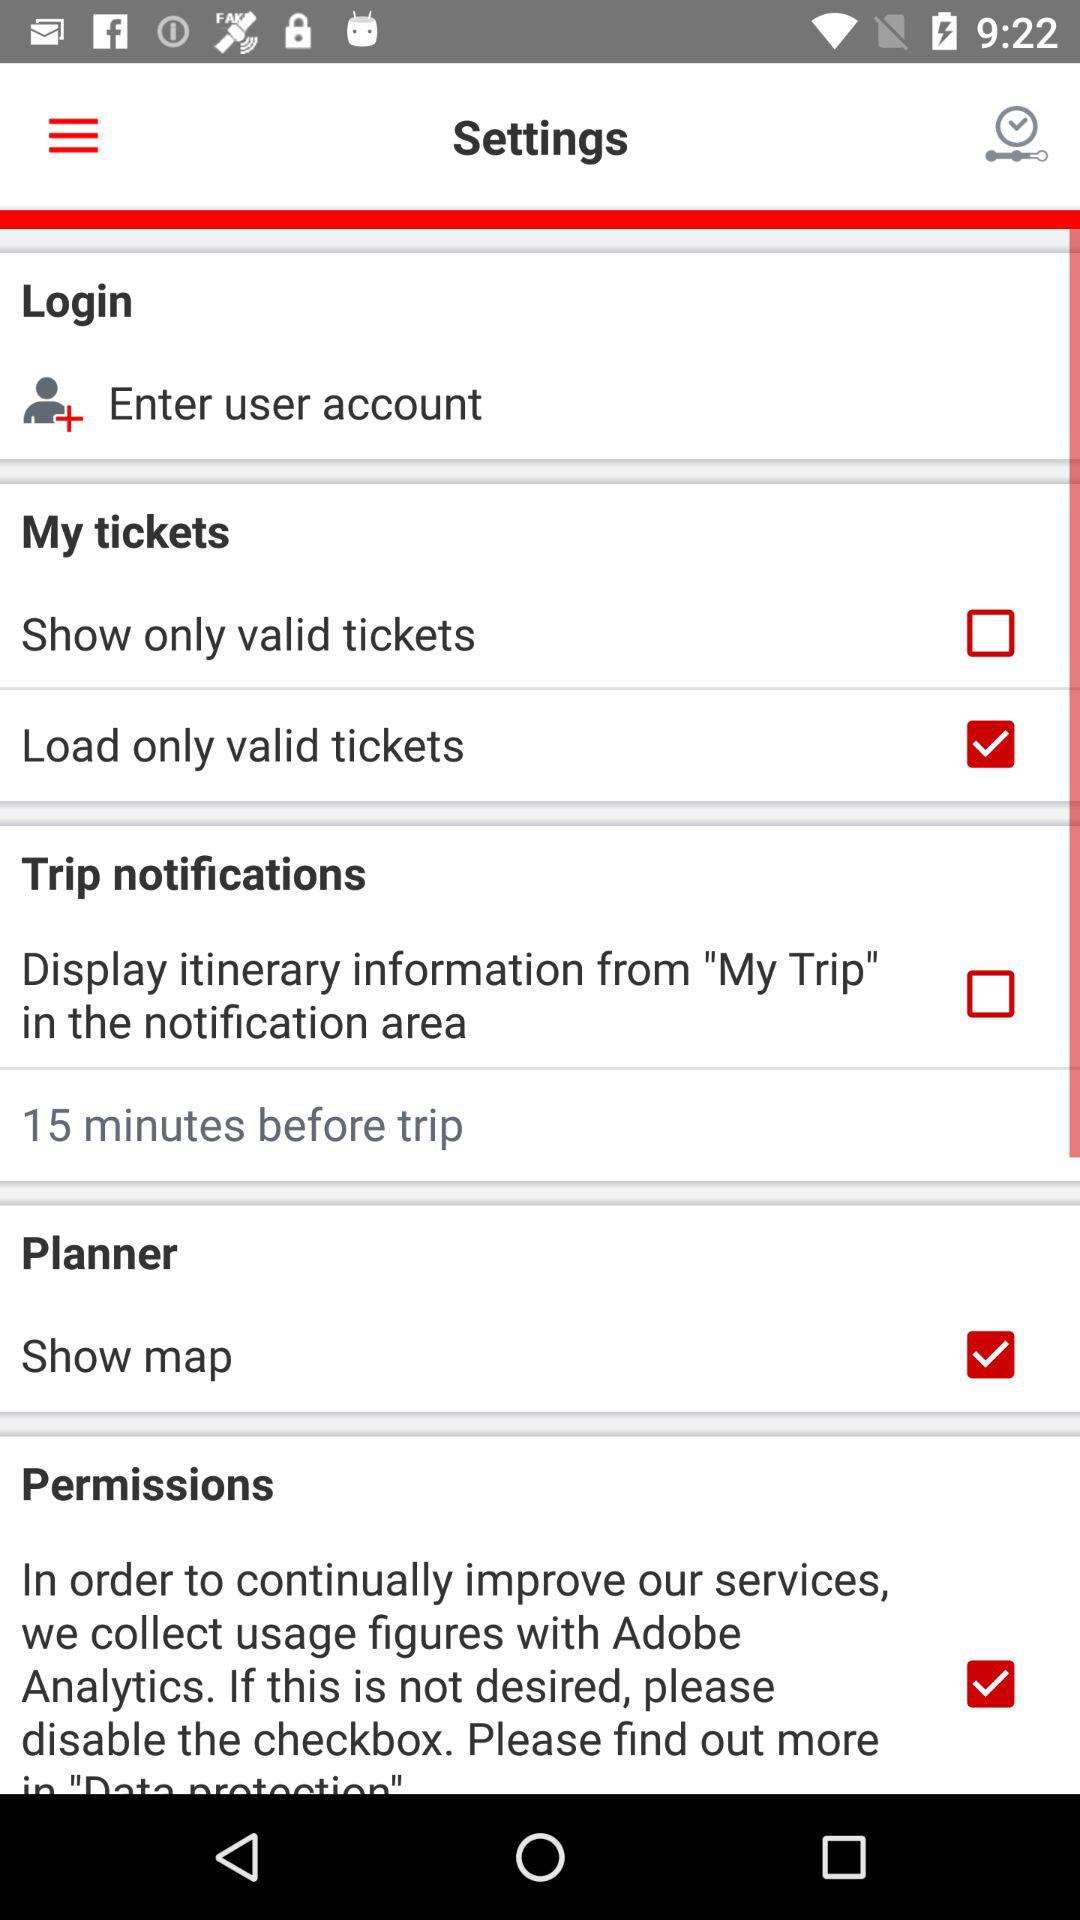What is the status of "Planner"? The status is "on". 